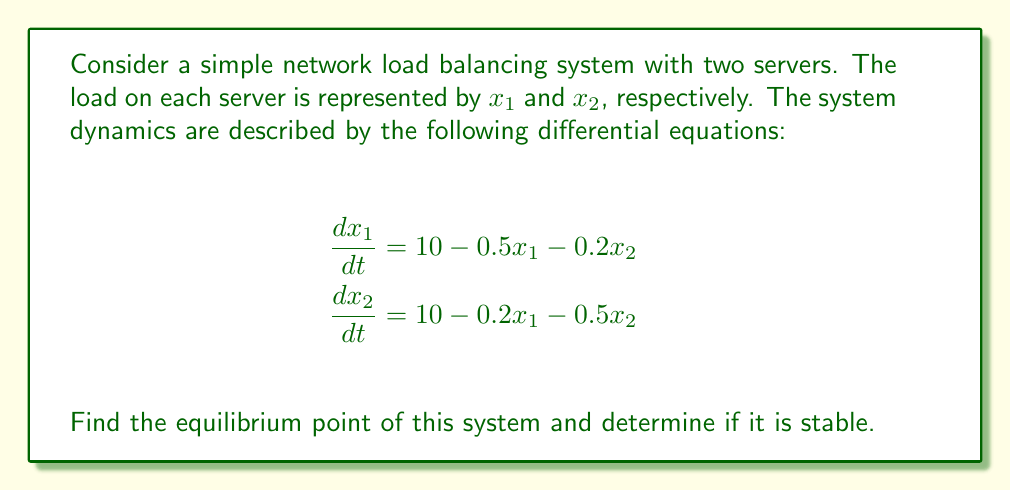Can you solve this math problem? 1. To find the equilibrium point, set both derivatives to zero:
   $$\frac{dx_1}{dt} = 10 - 0.5x_1 - 0.2x_2 = 0$$
   $$\frac{dx_2}{dt} = 10 - 0.2x_1 - 0.5x_2 = 0$$

2. Solve this system of linear equations:
   $$10 = 0.5x_1 + 0.2x_2$$
   $$10 = 0.2x_1 + 0.5x_2$$

3. Multiply the first equation by 5 and the second by 2:
   $$50 = 2.5x_1 + x_2$$
   $$20 = 0.4x_1 + x_2$$

4. Subtract the second equation from the first:
   $$30 = 2.1x_1$$
   $$x_1 = \frac{30}{2.1} \approx 14.29$$

5. Substitute this value back into one of the original equations:
   $$10 = 0.2(14.29) + 0.5x_2$$
   $$10 = 2.86 + 0.5x_2$$
   $$x_2 = \frac{7.14}{0.5} = 14.28$$

6. The equilibrium point is approximately $(14.29, 14.28)$.

7. To determine stability, we need to analyze the Jacobian matrix at the equilibrium point:
   $$J = \begin{bmatrix}
   -0.5 & -0.2 \\
   -0.2 & -0.5
   \end{bmatrix}$$

8. Calculate the eigenvalues of J:
   $$\det(J - \lambda I) = \begin{vmatrix}
   -0.5 - \lambda & -0.2 \\
   -0.2 & -0.5 - \lambda
   \end{vmatrix} = 0$$

   $$(-0.5 - \lambda)^2 - 0.04 = 0$$
   $$\lambda^2 + \lambda + 0.21 = 0$$

9. Solve this quadratic equation:
   $$\lambda = \frac{-1 \pm \sqrt{1^2 - 4(1)(0.21)}}{2(1)}$$
   $$\lambda = \frac{-1 \pm \sqrt{0.16}}{2} = -0.5 \pm 0.2$$

10. The eigenvalues are $\lambda_1 = -0.7$ and $\lambda_2 = -0.3$. Since both eigenvalues are negative, the equilibrium point is stable.
Answer: Equilibrium point: $(14.29, 14.28)$; Stable 